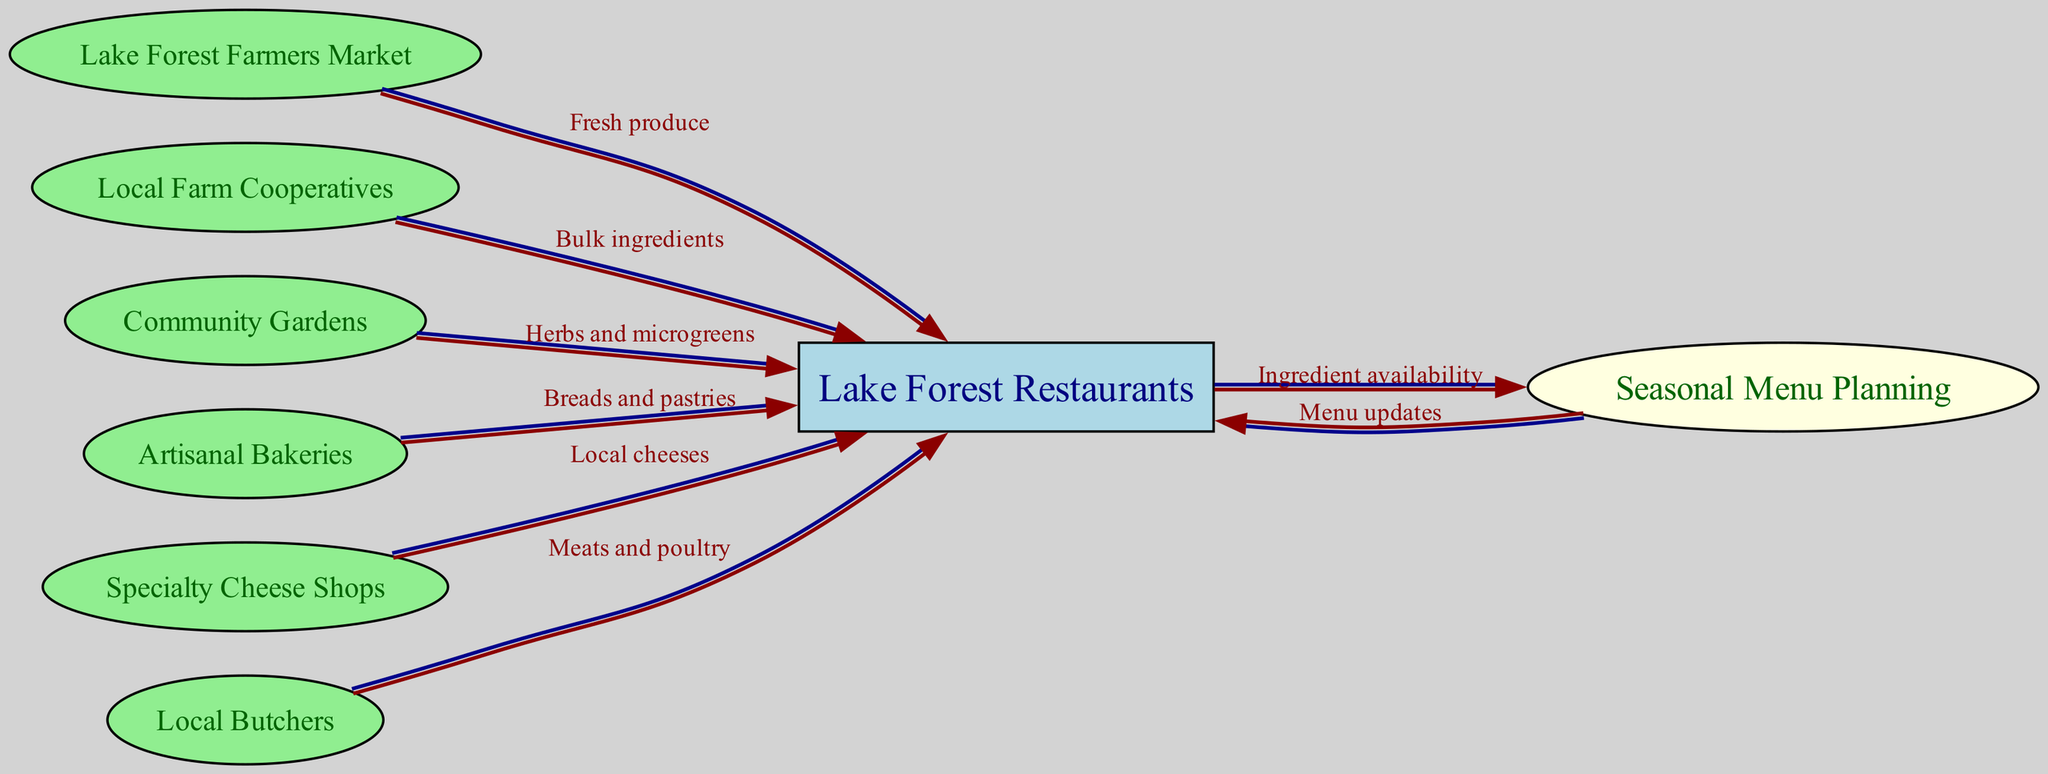What is the number of nodes in the diagram? The diagram includes nodes representing different entities involved in the supply chain. Counting all the unique nodes in the list provided, we have: Lake Forest Farmers Market, Local Farm Cooperatives, Community Gardens, Artisanal Bakeries, Specialty Cheese Shops, Local Butchers, Lake Forest Restaurants, and Seasonal Menu Planning, resulting in a total of 8 nodes.
Answer: 8 Which node supplies "Fresh produce" to the restaurants? The edge labeled "Fresh produce" points from the Lake Forest Farmers Market to the Lake Forest Restaurants, indicating that this market supplies fresh produce to the restaurants.
Answer: Lake Forest Farmers Market What type of ingredient is provided by local butchers? The edge labeled "Meats and poultry" indicates the type of ingredient supplied by Local Butchers. Since it directly connects to Lake Forest Restaurants, it means local butchers provide meats and poultry to the restaurants.
Answer: Meats and poultry How many edges connect to Lake Forest Restaurants? We see edges pointing from multiple nodes towards Lake Forest Restaurants: from Lake Forest Farmers Market, Local Farm Cooperatives, Community Gardens, Artisanal Bakeries, Specialty Cheese Shops, and Local Butchers. Counting these, there are 6 edges connecting to Lake Forest Restaurants.
Answer: 6 What is the relationship between Lake Forest Restaurants and Seasonal Menu Planning? There are two edges related to these nodes: one edge leads from Lake Forest Restaurants to Seasonal Menu Planning, labeled "Ingredient availability," and another edge leads back from Seasonal Menu Planning to Lake Forest Restaurants, labeled "Menu updates." This indicates a cyclical relationship involving menu updates based on ingredient availability.
Answer: Cyclical relationship Which node provides "Herbs and microgreens"? The edge labeled "Herbs and microgreens" indicates that this product is supplied from Community Gardens to Lake Forest Restaurants. Hence, Community Gardens is the node that provides these ingredients.
Answer: Community Gardens What is the main purpose of Seasonal Menu Planning in this supply chain? The diagram exhibits Seasonal Menu Planning as a key step influenced by the ingredient availability from Lake Forest Restaurants, which in turn updates the menu based on seasonal ingredient sources. Thus, the main purpose is to ensure that the menu aligns with the available ingredients.
Answer: Ensure menu alignment with ingredients How many types of ingredients are supplied by different nodes in the diagram? The edges indicate various types of ingredients supplied to Lake Forest Restaurants: Fresh produce, Bulk ingredients, Herbs and microgreens, Breads and pastries, Local cheeses, and Meats and poultry. Counting these distinct types, there are 6 different types of ingredients showcased in the diagram.
Answer: 6 What is the flow direction from Seasonal Menu Planning? The edge from Seasonal Menu Planning points back to Lake Forest Restaurants with the label "Menu updates." This means the flow direction from Seasonal Menu Planning is towards Lake Forest Restaurants.
Answer: Towards Lake Forest Restaurants 